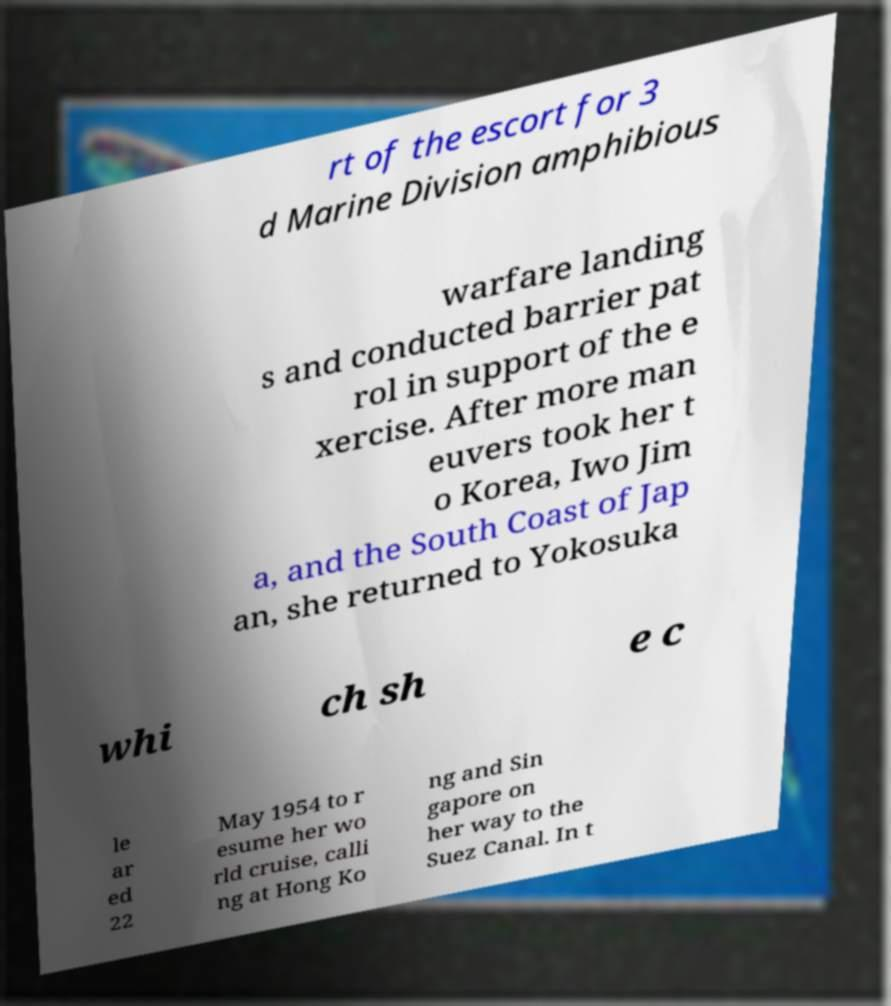Please read and relay the text visible in this image. What does it say? rt of the escort for 3 d Marine Division amphibious warfare landing s and conducted barrier pat rol in support of the e xercise. After more man euvers took her t o Korea, Iwo Jim a, and the South Coast of Jap an, she returned to Yokosuka whi ch sh e c le ar ed 22 May 1954 to r esume her wo rld cruise, calli ng at Hong Ko ng and Sin gapore on her way to the Suez Canal. In t 